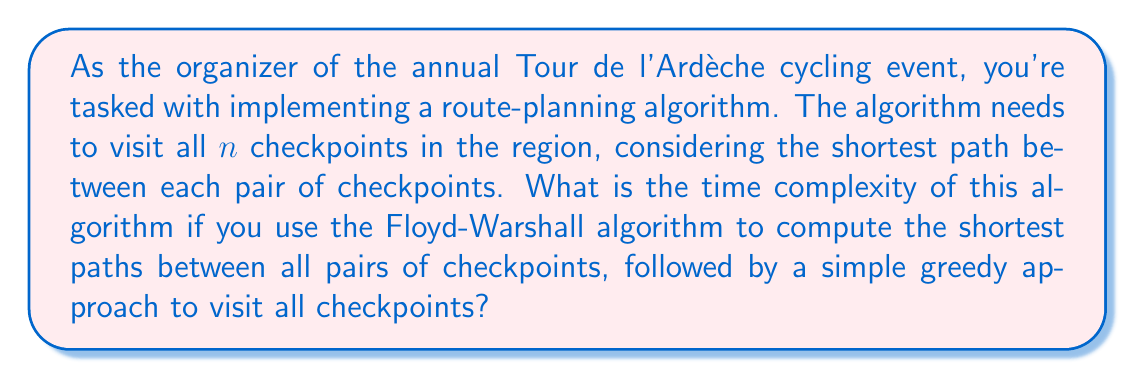Can you answer this question? To solve this problem, we need to break it down into two main steps:

1. Computing shortest paths between all pairs of checkpoints:
   - We use the Floyd-Warshall algorithm for this step.
   - The time complexity of Floyd-Warshall is $O(n^3)$, where $n$ is the number of vertices (checkpoints in our case).

2. Visiting all checkpoints using a greedy approach:
   - After computing all shortest paths, we use a simple greedy algorithm to visit all checkpoints.
   - This involves selecting the nearest unvisited checkpoint at each step.
   - The time complexity for this step is $O(n^2)$, as we need to check distances to all remaining checkpoints (at most $n-1$) for each of the $n$ checkpoints.

To determine the overall time complexity, we add these two steps:

$$T(n) = O(n^3) + O(n^2)$$

Since $O(n^3)$ grows faster than $O(n^2)$ as $n$ increases, we can simplify this to:

$$T(n) = O(n^3)$$

This is because the lower-order term $O(n^2)$ becomes insignificant compared to $O(n^3)$ for large values of $n$.
Answer: The time complexity of the route-planning algorithm is $O(n^3)$, where $n$ is the number of checkpoints. 